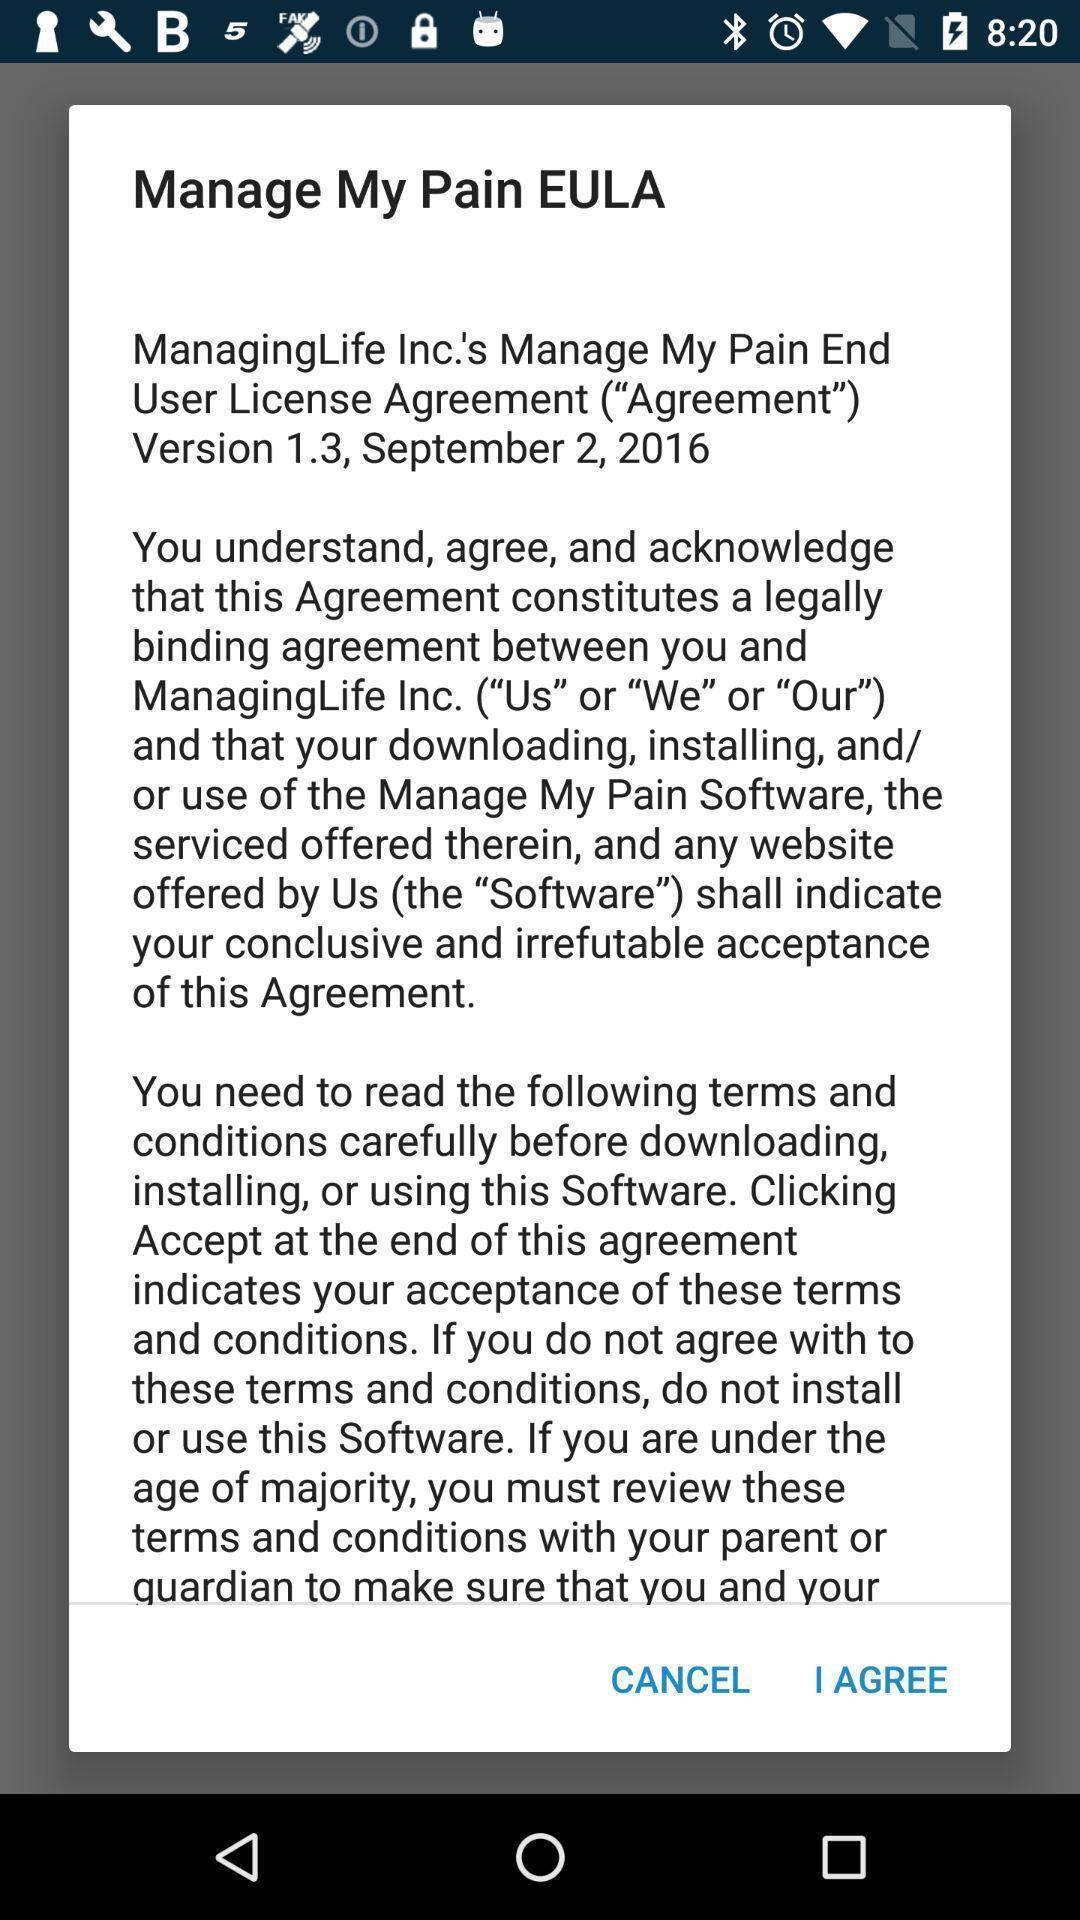Summarize the main components in this picture. Pop-up displays to agree policies in app. 